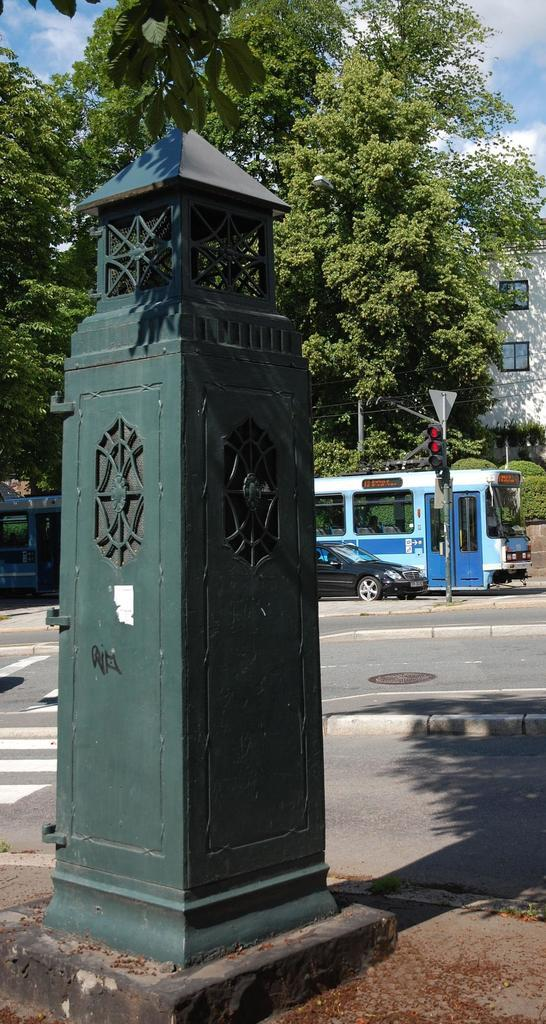What type of structure can be seen in the image? There is a metal structure in the image. What is happening on the road in the image? Vehicles are moving on the road in the image. What is the purpose of the pole in the image? There is a signal pole in the image, which is likely used for traffic signals or other signage. What can be seen in the distance in the image? There are trees and buildings in the background of the image. How many cows are grazing in the image? There are no cows present in the image. What is the wealth of the person driving the vehicle in the image? The image does not provide any information about the wealth of the person driving the vehicle. 